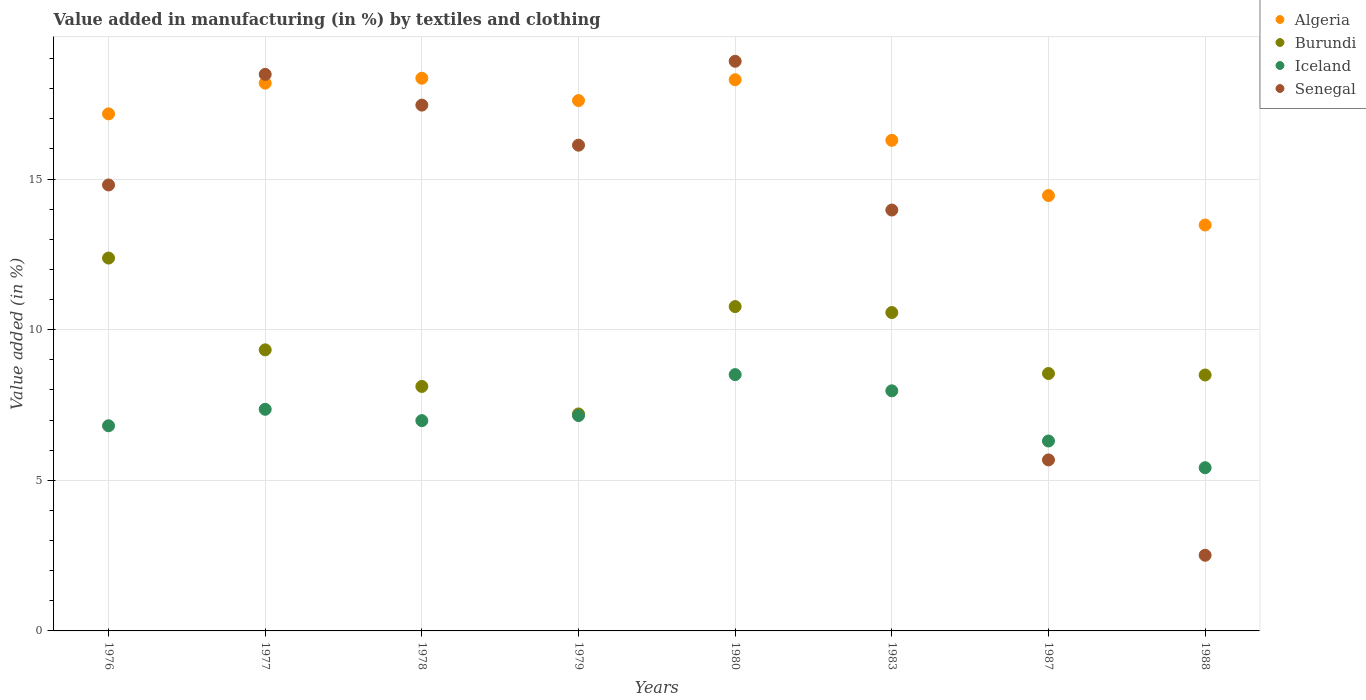How many different coloured dotlines are there?
Ensure brevity in your answer.  4. Is the number of dotlines equal to the number of legend labels?
Offer a very short reply. Yes. What is the percentage of value added in manufacturing by textiles and clothing in Burundi in 1983?
Your answer should be very brief. 10.57. Across all years, what is the maximum percentage of value added in manufacturing by textiles and clothing in Algeria?
Your response must be concise. 18.35. Across all years, what is the minimum percentage of value added in manufacturing by textiles and clothing in Iceland?
Your answer should be compact. 5.42. In which year was the percentage of value added in manufacturing by textiles and clothing in Burundi maximum?
Your answer should be very brief. 1976. What is the total percentage of value added in manufacturing by textiles and clothing in Burundi in the graph?
Keep it short and to the point. 75.4. What is the difference between the percentage of value added in manufacturing by textiles and clothing in Iceland in 1987 and that in 1988?
Make the answer very short. 0.89. What is the difference between the percentage of value added in manufacturing by textiles and clothing in Senegal in 1980 and the percentage of value added in manufacturing by textiles and clothing in Iceland in 1987?
Your answer should be compact. 12.6. What is the average percentage of value added in manufacturing by textiles and clothing in Burundi per year?
Your answer should be very brief. 9.42. In the year 1976, what is the difference between the percentage of value added in manufacturing by textiles and clothing in Algeria and percentage of value added in manufacturing by textiles and clothing in Senegal?
Provide a succinct answer. 2.36. In how many years, is the percentage of value added in manufacturing by textiles and clothing in Senegal greater than 14 %?
Ensure brevity in your answer.  5. What is the ratio of the percentage of value added in manufacturing by textiles and clothing in Algeria in 1976 to that in 1980?
Your answer should be compact. 0.94. Is the difference between the percentage of value added in manufacturing by textiles and clothing in Algeria in 1978 and 1988 greater than the difference between the percentage of value added in manufacturing by textiles and clothing in Senegal in 1978 and 1988?
Provide a short and direct response. No. What is the difference between the highest and the second highest percentage of value added in manufacturing by textiles and clothing in Iceland?
Offer a very short reply. 0.54. What is the difference between the highest and the lowest percentage of value added in manufacturing by textiles and clothing in Senegal?
Make the answer very short. 16.4. In how many years, is the percentage of value added in manufacturing by textiles and clothing in Algeria greater than the average percentage of value added in manufacturing by textiles and clothing in Algeria taken over all years?
Your answer should be very brief. 5. Is the sum of the percentage of value added in manufacturing by textiles and clothing in Algeria in 1978 and 1980 greater than the maximum percentage of value added in manufacturing by textiles and clothing in Senegal across all years?
Give a very brief answer. Yes. Does the percentage of value added in manufacturing by textiles and clothing in Iceland monotonically increase over the years?
Keep it short and to the point. No. Is the percentage of value added in manufacturing by textiles and clothing in Algeria strictly greater than the percentage of value added in manufacturing by textiles and clothing in Burundi over the years?
Keep it short and to the point. Yes. Is the percentage of value added in manufacturing by textiles and clothing in Senegal strictly less than the percentage of value added in manufacturing by textiles and clothing in Algeria over the years?
Your answer should be compact. No. What is the difference between two consecutive major ticks on the Y-axis?
Your response must be concise. 5. Are the values on the major ticks of Y-axis written in scientific E-notation?
Keep it short and to the point. No. Does the graph contain grids?
Your answer should be very brief. Yes. What is the title of the graph?
Give a very brief answer. Value added in manufacturing (in %) by textiles and clothing. What is the label or title of the X-axis?
Provide a short and direct response. Years. What is the label or title of the Y-axis?
Your answer should be very brief. Value added (in %). What is the Value added (in %) of Algeria in 1976?
Keep it short and to the point. 17.16. What is the Value added (in %) of Burundi in 1976?
Give a very brief answer. 12.38. What is the Value added (in %) of Iceland in 1976?
Your response must be concise. 6.81. What is the Value added (in %) in Senegal in 1976?
Ensure brevity in your answer.  14.8. What is the Value added (in %) in Algeria in 1977?
Keep it short and to the point. 18.18. What is the Value added (in %) of Burundi in 1977?
Offer a very short reply. 9.33. What is the Value added (in %) of Iceland in 1977?
Make the answer very short. 7.36. What is the Value added (in %) in Senegal in 1977?
Provide a succinct answer. 18.48. What is the Value added (in %) of Algeria in 1978?
Keep it short and to the point. 18.35. What is the Value added (in %) in Burundi in 1978?
Give a very brief answer. 8.12. What is the Value added (in %) of Iceland in 1978?
Your answer should be very brief. 6.98. What is the Value added (in %) of Senegal in 1978?
Your response must be concise. 17.45. What is the Value added (in %) in Algeria in 1979?
Your response must be concise. 17.6. What is the Value added (in %) of Burundi in 1979?
Give a very brief answer. 7.2. What is the Value added (in %) of Iceland in 1979?
Provide a short and direct response. 7.15. What is the Value added (in %) in Senegal in 1979?
Offer a very short reply. 16.12. What is the Value added (in %) of Algeria in 1980?
Your answer should be compact. 18.3. What is the Value added (in %) in Burundi in 1980?
Keep it short and to the point. 10.77. What is the Value added (in %) of Iceland in 1980?
Offer a terse response. 8.51. What is the Value added (in %) in Senegal in 1980?
Provide a succinct answer. 18.91. What is the Value added (in %) in Algeria in 1983?
Your answer should be very brief. 16.29. What is the Value added (in %) of Burundi in 1983?
Your answer should be very brief. 10.57. What is the Value added (in %) in Iceland in 1983?
Provide a short and direct response. 7.97. What is the Value added (in %) in Senegal in 1983?
Your answer should be very brief. 13.97. What is the Value added (in %) of Algeria in 1987?
Make the answer very short. 14.45. What is the Value added (in %) in Burundi in 1987?
Ensure brevity in your answer.  8.54. What is the Value added (in %) in Iceland in 1987?
Keep it short and to the point. 6.3. What is the Value added (in %) in Senegal in 1987?
Make the answer very short. 5.68. What is the Value added (in %) of Algeria in 1988?
Make the answer very short. 13.47. What is the Value added (in %) in Burundi in 1988?
Offer a very short reply. 8.5. What is the Value added (in %) in Iceland in 1988?
Your answer should be compact. 5.42. What is the Value added (in %) of Senegal in 1988?
Ensure brevity in your answer.  2.51. Across all years, what is the maximum Value added (in %) in Algeria?
Make the answer very short. 18.35. Across all years, what is the maximum Value added (in %) in Burundi?
Ensure brevity in your answer.  12.38. Across all years, what is the maximum Value added (in %) in Iceland?
Your answer should be compact. 8.51. Across all years, what is the maximum Value added (in %) of Senegal?
Offer a terse response. 18.91. Across all years, what is the minimum Value added (in %) of Algeria?
Your response must be concise. 13.47. Across all years, what is the minimum Value added (in %) in Burundi?
Provide a short and direct response. 7.2. Across all years, what is the minimum Value added (in %) in Iceland?
Make the answer very short. 5.42. Across all years, what is the minimum Value added (in %) of Senegal?
Provide a short and direct response. 2.51. What is the total Value added (in %) of Algeria in the graph?
Your response must be concise. 133.81. What is the total Value added (in %) of Burundi in the graph?
Your response must be concise. 75.4. What is the total Value added (in %) in Iceland in the graph?
Your answer should be compact. 56.49. What is the total Value added (in %) of Senegal in the graph?
Make the answer very short. 107.93. What is the difference between the Value added (in %) of Algeria in 1976 and that in 1977?
Your answer should be very brief. -1.02. What is the difference between the Value added (in %) in Burundi in 1976 and that in 1977?
Ensure brevity in your answer.  3.05. What is the difference between the Value added (in %) in Iceland in 1976 and that in 1977?
Your answer should be very brief. -0.55. What is the difference between the Value added (in %) in Senegal in 1976 and that in 1977?
Offer a terse response. -3.67. What is the difference between the Value added (in %) of Algeria in 1976 and that in 1978?
Your answer should be compact. -1.18. What is the difference between the Value added (in %) in Burundi in 1976 and that in 1978?
Your answer should be very brief. 4.26. What is the difference between the Value added (in %) in Iceland in 1976 and that in 1978?
Provide a succinct answer. -0.17. What is the difference between the Value added (in %) in Senegal in 1976 and that in 1978?
Give a very brief answer. -2.65. What is the difference between the Value added (in %) in Algeria in 1976 and that in 1979?
Offer a terse response. -0.44. What is the difference between the Value added (in %) of Burundi in 1976 and that in 1979?
Your answer should be compact. 5.17. What is the difference between the Value added (in %) of Iceland in 1976 and that in 1979?
Keep it short and to the point. -0.34. What is the difference between the Value added (in %) of Senegal in 1976 and that in 1979?
Provide a succinct answer. -1.32. What is the difference between the Value added (in %) of Algeria in 1976 and that in 1980?
Offer a very short reply. -1.13. What is the difference between the Value added (in %) of Burundi in 1976 and that in 1980?
Offer a terse response. 1.61. What is the difference between the Value added (in %) of Iceland in 1976 and that in 1980?
Keep it short and to the point. -1.7. What is the difference between the Value added (in %) of Senegal in 1976 and that in 1980?
Provide a short and direct response. -4.11. What is the difference between the Value added (in %) of Algeria in 1976 and that in 1983?
Offer a very short reply. 0.88. What is the difference between the Value added (in %) in Burundi in 1976 and that in 1983?
Offer a terse response. 1.81. What is the difference between the Value added (in %) in Iceland in 1976 and that in 1983?
Your answer should be very brief. -1.16. What is the difference between the Value added (in %) in Senegal in 1976 and that in 1983?
Provide a succinct answer. 0.83. What is the difference between the Value added (in %) of Algeria in 1976 and that in 1987?
Ensure brevity in your answer.  2.71. What is the difference between the Value added (in %) in Burundi in 1976 and that in 1987?
Keep it short and to the point. 3.83. What is the difference between the Value added (in %) of Iceland in 1976 and that in 1987?
Your answer should be very brief. 0.51. What is the difference between the Value added (in %) in Senegal in 1976 and that in 1987?
Your response must be concise. 9.13. What is the difference between the Value added (in %) of Algeria in 1976 and that in 1988?
Ensure brevity in your answer.  3.69. What is the difference between the Value added (in %) of Burundi in 1976 and that in 1988?
Your answer should be very brief. 3.88. What is the difference between the Value added (in %) in Iceland in 1976 and that in 1988?
Your answer should be very brief. 1.39. What is the difference between the Value added (in %) of Senegal in 1976 and that in 1988?
Offer a very short reply. 12.29. What is the difference between the Value added (in %) in Algeria in 1977 and that in 1978?
Provide a succinct answer. -0.16. What is the difference between the Value added (in %) in Burundi in 1977 and that in 1978?
Offer a terse response. 1.21. What is the difference between the Value added (in %) in Iceland in 1977 and that in 1978?
Ensure brevity in your answer.  0.38. What is the difference between the Value added (in %) of Senegal in 1977 and that in 1978?
Your answer should be very brief. 1.02. What is the difference between the Value added (in %) of Algeria in 1977 and that in 1979?
Your response must be concise. 0.58. What is the difference between the Value added (in %) of Burundi in 1977 and that in 1979?
Offer a very short reply. 2.13. What is the difference between the Value added (in %) of Iceland in 1977 and that in 1979?
Offer a very short reply. 0.21. What is the difference between the Value added (in %) of Senegal in 1977 and that in 1979?
Keep it short and to the point. 2.35. What is the difference between the Value added (in %) in Algeria in 1977 and that in 1980?
Make the answer very short. -0.11. What is the difference between the Value added (in %) in Burundi in 1977 and that in 1980?
Make the answer very short. -1.44. What is the difference between the Value added (in %) in Iceland in 1977 and that in 1980?
Provide a succinct answer. -1.15. What is the difference between the Value added (in %) of Senegal in 1977 and that in 1980?
Give a very brief answer. -0.43. What is the difference between the Value added (in %) in Algeria in 1977 and that in 1983?
Your answer should be compact. 1.9. What is the difference between the Value added (in %) in Burundi in 1977 and that in 1983?
Keep it short and to the point. -1.24. What is the difference between the Value added (in %) in Iceland in 1977 and that in 1983?
Offer a terse response. -0.61. What is the difference between the Value added (in %) in Senegal in 1977 and that in 1983?
Provide a succinct answer. 4.5. What is the difference between the Value added (in %) of Algeria in 1977 and that in 1987?
Your answer should be compact. 3.73. What is the difference between the Value added (in %) in Burundi in 1977 and that in 1987?
Provide a succinct answer. 0.79. What is the difference between the Value added (in %) in Iceland in 1977 and that in 1987?
Keep it short and to the point. 1.05. What is the difference between the Value added (in %) in Senegal in 1977 and that in 1987?
Give a very brief answer. 12.8. What is the difference between the Value added (in %) in Algeria in 1977 and that in 1988?
Ensure brevity in your answer.  4.71. What is the difference between the Value added (in %) of Burundi in 1977 and that in 1988?
Your answer should be very brief. 0.83. What is the difference between the Value added (in %) of Iceland in 1977 and that in 1988?
Provide a succinct answer. 1.94. What is the difference between the Value added (in %) in Senegal in 1977 and that in 1988?
Make the answer very short. 15.96. What is the difference between the Value added (in %) of Algeria in 1978 and that in 1979?
Your response must be concise. 0.74. What is the difference between the Value added (in %) in Burundi in 1978 and that in 1979?
Keep it short and to the point. 0.91. What is the difference between the Value added (in %) in Iceland in 1978 and that in 1979?
Make the answer very short. -0.17. What is the difference between the Value added (in %) of Senegal in 1978 and that in 1979?
Your answer should be very brief. 1.33. What is the difference between the Value added (in %) in Algeria in 1978 and that in 1980?
Keep it short and to the point. 0.05. What is the difference between the Value added (in %) of Burundi in 1978 and that in 1980?
Your answer should be compact. -2.65. What is the difference between the Value added (in %) of Iceland in 1978 and that in 1980?
Provide a succinct answer. -1.53. What is the difference between the Value added (in %) of Senegal in 1978 and that in 1980?
Make the answer very short. -1.45. What is the difference between the Value added (in %) in Algeria in 1978 and that in 1983?
Keep it short and to the point. 2.06. What is the difference between the Value added (in %) of Burundi in 1978 and that in 1983?
Provide a short and direct response. -2.45. What is the difference between the Value added (in %) in Iceland in 1978 and that in 1983?
Ensure brevity in your answer.  -0.99. What is the difference between the Value added (in %) of Senegal in 1978 and that in 1983?
Offer a very short reply. 3.48. What is the difference between the Value added (in %) of Algeria in 1978 and that in 1987?
Your response must be concise. 3.89. What is the difference between the Value added (in %) in Burundi in 1978 and that in 1987?
Provide a succinct answer. -0.43. What is the difference between the Value added (in %) of Iceland in 1978 and that in 1987?
Provide a short and direct response. 0.68. What is the difference between the Value added (in %) of Senegal in 1978 and that in 1987?
Offer a terse response. 11.78. What is the difference between the Value added (in %) of Algeria in 1978 and that in 1988?
Provide a short and direct response. 4.87. What is the difference between the Value added (in %) in Burundi in 1978 and that in 1988?
Your answer should be compact. -0.38. What is the difference between the Value added (in %) of Iceland in 1978 and that in 1988?
Your answer should be very brief. 1.56. What is the difference between the Value added (in %) of Senegal in 1978 and that in 1988?
Provide a short and direct response. 14.94. What is the difference between the Value added (in %) in Algeria in 1979 and that in 1980?
Ensure brevity in your answer.  -0.69. What is the difference between the Value added (in %) of Burundi in 1979 and that in 1980?
Your response must be concise. -3.56. What is the difference between the Value added (in %) in Iceland in 1979 and that in 1980?
Your answer should be compact. -1.36. What is the difference between the Value added (in %) in Senegal in 1979 and that in 1980?
Offer a very short reply. -2.78. What is the difference between the Value added (in %) of Algeria in 1979 and that in 1983?
Offer a very short reply. 1.32. What is the difference between the Value added (in %) of Burundi in 1979 and that in 1983?
Your answer should be very brief. -3.37. What is the difference between the Value added (in %) of Iceland in 1979 and that in 1983?
Provide a succinct answer. -0.82. What is the difference between the Value added (in %) of Senegal in 1979 and that in 1983?
Ensure brevity in your answer.  2.15. What is the difference between the Value added (in %) of Algeria in 1979 and that in 1987?
Keep it short and to the point. 3.15. What is the difference between the Value added (in %) in Burundi in 1979 and that in 1987?
Provide a succinct answer. -1.34. What is the difference between the Value added (in %) in Iceland in 1979 and that in 1987?
Offer a very short reply. 0.84. What is the difference between the Value added (in %) of Senegal in 1979 and that in 1987?
Your answer should be very brief. 10.45. What is the difference between the Value added (in %) in Algeria in 1979 and that in 1988?
Give a very brief answer. 4.13. What is the difference between the Value added (in %) in Burundi in 1979 and that in 1988?
Make the answer very short. -1.29. What is the difference between the Value added (in %) of Iceland in 1979 and that in 1988?
Offer a terse response. 1.73. What is the difference between the Value added (in %) in Senegal in 1979 and that in 1988?
Your response must be concise. 13.61. What is the difference between the Value added (in %) in Algeria in 1980 and that in 1983?
Your answer should be compact. 2.01. What is the difference between the Value added (in %) of Burundi in 1980 and that in 1983?
Offer a terse response. 0.2. What is the difference between the Value added (in %) of Iceland in 1980 and that in 1983?
Your answer should be compact. 0.54. What is the difference between the Value added (in %) of Senegal in 1980 and that in 1983?
Provide a short and direct response. 4.94. What is the difference between the Value added (in %) in Algeria in 1980 and that in 1987?
Your response must be concise. 3.84. What is the difference between the Value added (in %) of Burundi in 1980 and that in 1987?
Your answer should be very brief. 2.22. What is the difference between the Value added (in %) of Iceland in 1980 and that in 1987?
Your answer should be very brief. 2.2. What is the difference between the Value added (in %) of Senegal in 1980 and that in 1987?
Ensure brevity in your answer.  13.23. What is the difference between the Value added (in %) of Algeria in 1980 and that in 1988?
Offer a very short reply. 4.82. What is the difference between the Value added (in %) of Burundi in 1980 and that in 1988?
Provide a succinct answer. 2.27. What is the difference between the Value added (in %) of Iceland in 1980 and that in 1988?
Your answer should be compact. 3.09. What is the difference between the Value added (in %) in Senegal in 1980 and that in 1988?
Offer a very short reply. 16.4. What is the difference between the Value added (in %) of Algeria in 1983 and that in 1987?
Give a very brief answer. 1.83. What is the difference between the Value added (in %) of Burundi in 1983 and that in 1987?
Your answer should be very brief. 2.02. What is the difference between the Value added (in %) in Iceland in 1983 and that in 1987?
Provide a succinct answer. 1.67. What is the difference between the Value added (in %) in Senegal in 1983 and that in 1987?
Offer a terse response. 8.29. What is the difference between the Value added (in %) of Algeria in 1983 and that in 1988?
Your response must be concise. 2.81. What is the difference between the Value added (in %) in Burundi in 1983 and that in 1988?
Ensure brevity in your answer.  2.07. What is the difference between the Value added (in %) of Iceland in 1983 and that in 1988?
Make the answer very short. 2.55. What is the difference between the Value added (in %) in Senegal in 1983 and that in 1988?
Keep it short and to the point. 11.46. What is the difference between the Value added (in %) in Algeria in 1987 and that in 1988?
Provide a short and direct response. 0.98. What is the difference between the Value added (in %) of Burundi in 1987 and that in 1988?
Provide a succinct answer. 0.05. What is the difference between the Value added (in %) of Iceland in 1987 and that in 1988?
Provide a short and direct response. 0.89. What is the difference between the Value added (in %) of Senegal in 1987 and that in 1988?
Keep it short and to the point. 3.17. What is the difference between the Value added (in %) in Algeria in 1976 and the Value added (in %) in Burundi in 1977?
Provide a short and direct response. 7.83. What is the difference between the Value added (in %) of Algeria in 1976 and the Value added (in %) of Iceland in 1977?
Provide a succinct answer. 9.81. What is the difference between the Value added (in %) in Algeria in 1976 and the Value added (in %) in Senegal in 1977?
Make the answer very short. -1.31. What is the difference between the Value added (in %) of Burundi in 1976 and the Value added (in %) of Iceland in 1977?
Provide a succinct answer. 5.02. What is the difference between the Value added (in %) of Burundi in 1976 and the Value added (in %) of Senegal in 1977?
Give a very brief answer. -6.1. What is the difference between the Value added (in %) of Iceland in 1976 and the Value added (in %) of Senegal in 1977?
Provide a succinct answer. -11.67. What is the difference between the Value added (in %) of Algeria in 1976 and the Value added (in %) of Burundi in 1978?
Ensure brevity in your answer.  9.05. What is the difference between the Value added (in %) of Algeria in 1976 and the Value added (in %) of Iceland in 1978?
Offer a very short reply. 10.18. What is the difference between the Value added (in %) of Algeria in 1976 and the Value added (in %) of Senegal in 1978?
Offer a terse response. -0.29. What is the difference between the Value added (in %) in Burundi in 1976 and the Value added (in %) in Iceland in 1978?
Provide a succinct answer. 5.4. What is the difference between the Value added (in %) in Burundi in 1976 and the Value added (in %) in Senegal in 1978?
Provide a short and direct response. -5.08. What is the difference between the Value added (in %) in Iceland in 1976 and the Value added (in %) in Senegal in 1978?
Make the answer very short. -10.64. What is the difference between the Value added (in %) of Algeria in 1976 and the Value added (in %) of Burundi in 1979?
Your response must be concise. 9.96. What is the difference between the Value added (in %) in Algeria in 1976 and the Value added (in %) in Iceland in 1979?
Your answer should be compact. 10.02. What is the difference between the Value added (in %) of Algeria in 1976 and the Value added (in %) of Senegal in 1979?
Offer a terse response. 1.04. What is the difference between the Value added (in %) in Burundi in 1976 and the Value added (in %) in Iceland in 1979?
Your response must be concise. 5.23. What is the difference between the Value added (in %) in Burundi in 1976 and the Value added (in %) in Senegal in 1979?
Give a very brief answer. -3.75. What is the difference between the Value added (in %) of Iceland in 1976 and the Value added (in %) of Senegal in 1979?
Provide a short and direct response. -9.31. What is the difference between the Value added (in %) of Algeria in 1976 and the Value added (in %) of Burundi in 1980?
Offer a very short reply. 6.4. What is the difference between the Value added (in %) in Algeria in 1976 and the Value added (in %) in Iceland in 1980?
Your answer should be compact. 8.66. What is the difference between the Value added (in %) in Algeria in 1976 and the Value added (in %) in Senegal in 1980?
Make the answer very short. -1.75. What is the difference between the Value added (in %) of Burundi in 1976 and the Value added (in %) of Iceland in 1980?
Provide a succinct answer. 3.87. What is the difference between the Value added (in %) in Burundi in 1976 and the Value added (in %) in Senegal in 1980?
Offer a very short reply. -6.53. What is the difference between the Value added (in %) in Iceland in 1976 and the Value added (in %) in Senegal in 1980?
Offer a very short reply. -12.1. What is the difference between the Value added (in %) of Algeria in 1976 and the Value added (in %) of Burundi in 1983?
Give a very brief answer. 6.6. What is the difference between the Value added (in %) in Algeria in 1976 and the Value added (in %) in Iceland in 1983?
Keep it short and to the point. 9.19. What is the difference between the Value added (in %) of Algeria in 1976 and the Value added (in %) of Senegal in 1983?
Keep it short and to the point. 3.19. What is the difference between the Value added (in %) of Burundi in 1976 and the Value added (in %) of Iceland in 1983?
Your answer should be compact. 4.41. What is the difference between the Value added (in %) in Burundi in 1976 and the Value added (in %) in Senegal in 1983?
Provide a succinct answer. -1.59. What is the difference between the Value added (in %) of Iceland in 1976 and the Value added (in %) of Senegal in 1983?
Your response must be concise. -7.16. What is the difference between the Value added (in %) of Algeria in 1976 and the Value added (in %) of Burundi in 1987?
Provide a succinct answer. 8.62. What is the difference between the Value added (in %) of Algeria in 1976 and the Value added (in %) of Iceland in 1987?
Provide a succinct answer. 10.86. What is the difference between the Value added (in %) of Algeria in 1976 and the Value added (in %) of Senegal in 1987?
Ensure brevity in your answer.  11.49. What is the difference between the Value added (in %) of Burundi in 1976 and the Value added (in %) of Iceland in 1987?
Provide a succinct answer. 6.07. What is the difference between the Value added (in %) in Burundi in 1976 and the Value added (in %) in Senegal in 1987?
Provide a short and direct response. 6.7. What is the difference between the Value added (in %) in Iceland in 1976 and the Value added (in %) in Senegal in 1987?
Provide a short and direct response. 1.13. What is the difference between the Value added (in %) of Algeria in 1976 and the Value added (in %) of Burundi in 1988?
Give a very brief answer. 8.67. What is the difference between the Value added (in %) of Algeria in 1976 and the Value added (in %) of Iceland in 1988?
Ensure brevity in your answer.  11.75. What is the difference between the Value added (in %) of Algeria in 1976 and the Value added (in %) of Senegal in 1988?
Give a very brief answer. 14.65. What is the difference between the Value added (in %) in Burundi in 1976 and the Value added (in %) in Iceland in 1988?
Your response must be concise. 6.96. What is the difference between the Value added (in %) of Burundi in 1976 and the Value added (in %) of Senegal in 1988?
Give a very brief answer. 9.86. What is the difference between the Value added (in %) of Iceland in 1976 and the Value added (in %) of Senegal in 1988?
Keep it short and to the point. 4.3. What is the difference between the Value added (in %) in Algeria in 1977 and the Value added (in %) in Burundi in 1978?
Provide a succinct answer. 10.07. What is the difference between the Value added (in %) of Algeria in 1977 and the Value added (in %) of Iceland in 1978?
Make the answer very short. 11.2. What is the difference between the Value added (in %) of Algeria in 1977 and the Value added (in %) of Senegal in 1978?
Keep it short and to the point. 0.73. What is the difference between the Value added (in %) of Burundi in 1977 and the Value added (in %) of Iceland in 1978?
Offer a very short reply. 2.35. What is the difference between the Value added (in %) of Burundi in 1977 and the Value added (in %) of Senegal in 1978?
Provide a succinct answer. -8.12. What is the difference between the Value added (in %) of Iceland in 1977 and the Value added (in %) of Senegal in 1978?
Your answer should be very brief. -10.1. What is the difference between the Value added (in %) of Algeria in 1977 and the Value added (in %) of Burundi in 1979?
Provide a succinct answer. 10.98. What is the difference between the Value added (in %) of Algeria in 1977 and the Value added (in %) of Iceland in 1979?
Your answer should be very brief. 11.04. What is the difference between the Value added (in %) of Algeria in 1977 and the Value added (in %) of Senegal in 1979?
Your response must be concise. 2.06. What is the difference between the Value added (in %) of Burundi in 1977 and the Value added (in %) of Iceland in 1979?
Give a very brief answer. 2.18. What is the difference between the Value added (in %) of Burundi in 1977 and the Value added (in %) of Senegal in 1979?
Your response must be concise. -6.79. What is the difference between the Value added (in %) of Iceland in 1977 and the Value added (in %) of Senegal in 1979?
Provide a succinct answer. -8.77. What is the difference between the Value added (in %) of Algeria in 1977 and the Value added (in %) of Burundi in 1980?
Provide a succinct answer. 7.42. What is the difference between the Value added (in %) in Algeria in 1977 and the Value added (in %) in Iceland in 1980?
Your answer should be very brief. 9.68. What is the difference between the Value added (in %) of Algeria in 1977 and the Value added (in %) of Senegal in 1980?
Provide a short and direct response. -0.73. What is the difference between the Value added (in %) in Burundi in 1977 and the Value added (in %) in Iceland in 1980?
Provide a short and direct response. 0.82. What is the difference between the Value added (in %) of Burundi in 1977 and the Value added (in %) of Senegal in 1980?
Provide a short and direct response. -9.58. What is the difference between the Value added (in %) of Iceland in 1977 and the Value added (in %) of Senegal in 1980?
Your answer should be compact. -11.55. What is the difference between the Value added (in %) in Algeria in 1977 and the Value added (in %) in Burundi in 1983?
Provide a short and direct response. 7.61. What is the difference between the Value added (in %) in Algeria in 1977 and the Value added (in %) in Iceland in 1983?
Your response must be concise. 10.21. What is the difference between the Value added (in %) in Algeria in 1977 and the Value added (in %) in Senegal in 1983?
Offer a very short reply. 4.21. What is the difference between the Value added (in %) of Burundi in 1977 and the Value added (in %) of Iceland in 1983?
Your response must be concise. 1.36. What is the difference between the Value added (in %) of Burundi in 1977 and the Value added (in %) of Senegal in 1983?
Your answer should be very brief. -4.64. What is the difference between the Value added (in %) of Iceland in 1977 and the Value added (in %) of Senegal in 1983?
Keep it short and to the point. -6.61. What is the difference between the Value added (in %) of Algeria in 1977 and the Value added (in %) of Burundi in 1987?
Your answer should be compact. 9.64. What is the difference between the Value added (in %) in Algeria in 1977 and the Value added (in %) in Iceland in 1987?
Provide a short and direct response. 11.88. What is the difference between the Value added (in %) in Algeria in 1977 and the Value added (in %) in Senegal in 1987?
Your answer should be very brief. 12.51. What is the difference between the Value added (in %) in Burundi in 1977 and the Value added (in %) in Iceland in 1987?
Your response must be concise. 3.03. What is the difference between the Value added (in %) in Burundi in 1977 and the Value added (in %) in Senegal in 1987?
Give a very brief answer. 3.65. What is the difference between the Value added (in %) of Iceland in 1977 and the Value added (in %) of Senegal in 1987?
Make the answer very short. 1.68. What is the difference between the Value added (in %) of Algeria in 1977 and the Value added (in %) of Burundi in 1988?
Ensure brevity in your answer.  9.69. What is the difference between the Value added (in %) of Algeria in 1977 and the Value added (in %) of Iceland in 1988?
Your answer should be compact. 12.77. What is the difference between the Value added (in %) of Algeria in 1977 and the Value added (in %) of Senegal in 1988?
Give a very brief answer. 15.67. What is the difference between the Value added (in %) of Burundi in 1977 and the Value added (in %) of Iceland in 1988?
Your answer should be very brief. 3.91. What is the difference between the Value added (in %) of Burundi in 1977 and the Value added (in %) of Senegal in 1988?
Offer a very short reply. 6.82. What is the difference between the Value added (in %) in Iceland in 1977 and the Value added (in %) in Senegal in 1988?
Provide a short and direct response. 4.85. What is the difference between the Value added (in %) of Algeria in 1978 and the Value added (in %) of Burundi in 1979?
Make the answer very short. 11.14. What is the difference between the Value added (in %) in Algeria in 1978 and the Value added (in %) in Iceland in 1979?
Your answer should be very brief. 11.2. What is the difference between the Value added (in %) of Algeria in 1978 and the Value added (in %) of Senegal in 1979?
Offer a very short reply. 2.22. What is the difference between the Value added (in %) in Burundi in 1978 and the Value added (in %) in Iceland in 1979?
Provide a succinct answer. 0.97. What is the difference between the Value added (in %) of Burundi in 1978 and the Value added (in %) of Senegal in 1979?
Offer a very short reply. -8.01. What is the difference between the Value added (in %) of Iceland in 1978 and the Value added (in %) of Senegal in 1979?
Ensure brevity in your answer.  -9.14. What is the difference between the Value added (in %) of Algeria in 1978 and the Value added (in %) of Burundi in 1980?
Your answer should be very brief. 7.58. What is the difference between the Value added (in %) of Algeria in 1978 and the Value added (in %) of Iceland in 1980?
Your answer should be very brief. 9.84. What is the difference between the Value added (in %) in Algeria in 1978 and the Value added (in %) in Senegal in 1980?
Your answer should be very brief. -0.56. What is the difference between the Value added (in %) in Burundi in 1978 and the Value added (in %) in Iceland in 1980?
Your answer should be compact. -0.39. What is the difference between the Value added (in %) in Burundi in 1978 and the Value added (in %) in Senegal in 1980?
Ensure brevity in your answer.  -10.79. What is the difference between the Value added (in %) of Iceland in 1978 and the Value added (in %) of Senegal in 1980?
Keep it short and to the point. -11.93. What is the difference between the Value added (in %) in Algeria in 1978 and the Value added (in %) in Burundi in 1983?
Provide a succinct answer. 7.78. What is the difference between the Value added (in %) in Algeria in 1978 and the Value added (in %) in Iceland in 1983?
Your response must be concise. 10.38. What is the difference between the Value added (in %) of Algeria in 1978 and the Value added (in %) of Senegal in 1983?
Give a very brief answer. 4.37. What is the difference between the Value added (in %) of Burundi in 1978 and the Value added (in %) of Iceland in 1983?
Your response must be concise. 0.15. What is the difference between the Value added (in %) in Burundi in 1978 and the Value added (in %) in Senegal in 1983?
Provide a short and direct response. -5.86. What is the difference between the Value added (in %) in Iceland in 1978 and the Value added (in %) in Senegal in 1983?
Offer a very short reply. -6.99. What is the difference between the Value added (in %) in Algeria in 1978 and the Value added (in %) in Burundi in 1987?
Make the answer very short. 9.8. What is the difference between the Value added (in %) of Algeria in 1978 and the Value added (in %) of Iceland in 1987?
Make the answer very short. 12.04. What is the difference between the Value added (in %) in Algeria in 1978 and the Value added (in %) in Senegal in 1987?
Your answer should be very brief. 12.67. What is the difference between the Value added (in %) in Burundi in 1978 and the Value added (in %) in Iceland in 1987?
Keep it short and to the point. 1.81. What is the difference between the Value added (in %) of Burundi in 1978 and the Value added (in %) of Senegal in 1987?
Your answer should be compact. 2.44. What is the difference between the Value added (in %) in Iceland in 1978 and the Value added (in %) in Senegal in 1987?
Keep it short and to the point. 1.3. What is the difference between the Value added (in %) in Algeria in 1978 and the Value added (in %) in Burundi in 1988?
Offer a terse response. 9.85. What is the difference between the Value added (in %) in Algeria in 1978 and the Value added (in %) in Iceland in 1988?
Ensure brevity in your answer.  12.93. What is the difference between the Value added (in %) of Algeria in 1978 and the Value added (in %) of Senegal in 1988?
Your answer should be very brief. 15.83. What is the difference between the Value added (in %) of Burundi in 1978 and the Value added (in %) of Iceland in 1988?
Offer a very short reply. 2.7. What is the difference between the Value added (in %) of Burundi in 1978 and the Value added (in %) of Senegal in 1988?
Your answer should be compact. 5.6. What is the difference between the Value added (in %) in Iceland in 1978 and the Value added (in %) in Senegal in 1988?
Offer a terse response. 4.47. What is the difference between the Value added (in %) of Algeria in 1979 and the Value added (in %) of Burundi in 1980?
Your answer should be very brief. 6.84. What is the difference between the Value added (in %) of Algeria in 1979 and the Value added (in %) of Iceland in 1980?
Your answer should be very brief. 9.1. What is the difference between the Value added (in %) of Algeria in 1979 and the Value added (in %) of Senegal in 1980?
Keep it short and to the point. -1.3. What is the difference between the Value added (in %) in Burundi in 1979 and the Value added (in %) in Iceland in 1980?
Provide a short and direct response. -1.31. What is the difference between the Value added (in %) of Burundi in 1979 and the Value added (in %) of Senegal in 1980?
Your response must be concise. -11.71. What is the difference between the Value added (in %) in Iceland in 1979 and the Value added (in %) in Senegal in 1980?
Your response must be concise. -11.76. What is the difference between the Value added (in %) in Algeria in 1979 and the Value added (in %) in Burundi in 1983?
Your response must be concise. 7.04. What is the difference between the Value added (in %) of Algeria in 1979 and the Value added (in %) of Iceland in 1983?
Offer a terse response. 9.63. What is the difference between the Value added (in %) of Algeria in 1979 and the Value added (in %) of Senegal in 1983?
Make the answer very short. 3.63. What is the difference between the Value added (in %) of Burundi in 1979 and the Value added (in %) of Iceland in 1983?
Ensure brevity in your answer.  -0.77. What is the difference between the Value added (in %) in Burundi in 1979 and the Value added (in %) in Senegal in 1983?
Offer a terse response. -6.77. What is the difference between the Value added (in %) in Iceland in 1979 and the Value added (in %) in Senegal in 1983?
Provide a short and direct response. -6.82. What is the difference between the Value added (in %) in Algeria in 1979 and the Value added (in %) in Burundi in 1987?
Provide a succinct answer. 9.06. What is the difference between the Value added (in %) in Algeria in 1979 and the Value added (in %) in Iceland in 1987?
Your answer should be compact. 11.3. What is the difference between the Value added (in %) in Algeria in 1979 and the Value added (in %) in Senegal in 1987?
Keep it short and to the point. 11.93. What is the difference between the Value added (in %) of Burundi in 1979 and the Value added (in %) of Iceland in 1987?
Ensure brevity in your answer.  0.9. What is the difference between the Value added (in %) of Burundi in 1979 and the Value added (in %) of Senegal in 1987?
Offer a very short reply. 1.53. What is the difference between the Value added (in %) in Iceland in 1979 and the Value added (in %) in Senegal in 1987?
Your answer should be compact. 1.47. What is the difference between the Value added (in %) of Algeria in 1979 and the Value added (in %) of Burundi in 1988?
Your answer should be very brief. 9.11. What is the difference between the Value added (in %) in Algeria in 1979 and the Value added (in %) in Iceland in 1988?
Offer a very short reply. 12.19. What is the difference between the Value added (in %) in Algeria in 1979 and the Value added (in %) in Senegal in 1988?
Your answer should be very brief. 15.09. What is the difference between the Value added (in %) of Burundi in 1979 and the Value added (in %) of Iceland in 1988?
Provide a succinct answer. 1.78. What is the difference between the Value added (in %) of Burundi in 1979 and the Value added (in %) of Senegal in 1988?
Keep it short and to the point. 4.69. What is the difference between the Value added (in %) of Iceland in 1979 and the Value added (in %) of Senegal in 1988?
Your answer should be compact. 4.64. What is the difference between the Value added (in %) in Algeria in 1980 and the Value added (in %) in Burundi in 1983?
Provide a succinct answer. 7.73. What is the difference between the Value added (in %) in Algeria in 1980 and the Value added (in %) in Iceland in 1983?
Your answer should be compact. 10.33. What is the difference between the Value added (in %) in Algeria in 1980 and the Value added (in %) in Senegal in 1983?
Provide a succinct answer. 4.33. What is the difference between the Value added (in %) of Burundi in 1980 and the Value added (in %) of Iceland in 1983?
Provide a succinct answer. 2.8. What is the difference between the Value added (in %) in Burundi in 1980 and the Value added (in %) in Senegal in 1983?
Your answer should be compact. -3.2. What is the difference between the Value added (in %) in Iceland in 1980 and the Value added (in %) in Senegal in 1983?
Offer a very short reply. -5.46. What is the difference between the Value added (in %) of Algeria in 1980 and the Value added (in %) of Burundi in 1987?
Make the answer very short. 9.75. What is the difference between the Value added (in %) in Algeria in 1980 and the Value added (in %) in Iceland in 1987?
Offer a terse response. 11.99. What is the difference between the Value added (in %) of Algeria in 1980 and the Value added (in %) of Senegal in 1987?
Your answer should be compact. 12.62. What is the difference between the Value added (in %) of Burundi in 1980 and the Value added (in %) of Iceland in 1987?
Your answer should be compact. 4.46. What is the difference between the Value added (in %) of Burundi in 1980 and the Value added (in %) of Senegal in 1987?
Your answer should be very brief. 5.09. What is the difference between the Value added (in %) of Iceland in 1980 and the Value added (in %) of Senegal in 1987?
Provide a short and direct response. 2.83. What is the difference between the Value added (in %) in Algeria in 1980 and the Value added (in %) in Burundi in 1988?
Provide a short and direct response. 9.8. What is the difference between the Value added (in %) in Algeria in 1980 and the Value added (in %) in Iceland in 1988?
Make the answer very short. 12.88. What is the difference between the Value added (in %) of Algeria in 1980 and the Value added (in %) of Senegal in 1988?
Your response must be concise. 15.78. What is the difference between the Value added (in %) of Burundi in 1980 and the Value added (in %) of Iceland in 1988?
Provide a succinct answer. 5.35. What is the difference between the Value added (in %) in Burundi in 1980 and the Value added (in %) in Senegal in 1988?
Provide a succinct answer. 8.25. What is the difference between the Value added (in %) in Iceland in 1980 and the Value added (in %) in Senegal in 1988?
Provide a short and direct response. 6. What is the difference between the Value added (in %) in Algeria in 1983 and the Value added (in %) in Burundi in 1987?
Offer a terse response. 7.74. What is the difference between the Value added (in %) of Algeria in 1983 and the Value added (in %) of Iceland in 1987?
Keep it short and to the point. 9.98. What is the difference between the Value added (in %) in Algeria in 1983 and the Value added (in %) in Senegal in 1987?
Keep it short and to the point. 10.61. What is the difference between the Value added (in %) in Burundi in 1983 and the Value added (in %) in Iceland in 1987?
Keep it short and to the point. 4.26. What is the difference between the Value added (in %) of Burundi in 1983 and the Value added (in %) of Senegal in 1987?
Keep it short and to the point. 4.89. What is the difference between the Value added (in %) of Iceland in 1983 and the Value added (in %) of Senegal in 1987?
Your response must be concise. 2.29. What is the difference between the Value added (in %) of Algeria in 1983 and the Value added (in %) of Burundi in 1988?
Your response must be concise. 7.79. What is the difference between the Value added (in %) of Algeria in 1983 and the Value added (in %) of Iceland in 1988?
Ensure brevity in your answer.  10.87. What is the difference between the Value added (in %) in Algeria in 1983 and the Value added (in %) in Senegal in 1988?
Your answer should be very brief. 13.77. What is the difference between the Value added (in %) in Burundi in 1983 and the Value added (in %) in Iceland in 1988?
Offer a terse response. 5.15. What is the difference between the Value added (in %) in Burundi in 1983 and the Value added (in %) in Senegal in 1988?
Your response must be concise. 8.06. What is the difference between the Value added (in %) of Iceland in 1983 and the Value added (in %) of Senegal in 1988?
Offer a very short reply. 5.46. What is the difference between the Value added (in %) of Algeria in 1987 and the Value added (in %) of Burundi in 1988?
Offer a terse response. 5.96. What is the difference between the Value added (in %) in Algeria in 1987 and the Value added (in %) in Iceland in 1988?
Provide a short and direct response. 9.04. What is the difference between the Value added (in %) in Algeria in 1987 and the Value added (in %) in Senegal in 1988?
Give a very brief answer. 11.94. What is the difference between the Value added (in %) of Burundi in 1987 and the Value added (in %) of Iceland in 1988?
Provide a short and direct response. 3.13. What is the difference between the Value added (in %) in Burundi in 1987 and the Value added (in %) in Senegal in 1988?
Your answer should be very brief. 6.03. What is the difference between the Value added (in %) of Iceland in 1987 and the Value added (in %) of Senegal in 1988?
Offer a very short reply. 3.79. What is the average Value added (in %) in Algeria per year?
Provide a succinct answer. 16.73. What is the average Value added (in %) in Burundi per year?
Provide a short and direct response. 9.42. What is the average Value added (in %) in Iceland per year?
Offer a very short reply. 7.06. What is the average Value added (in %) in Senegal per year?
Give a very brief answer. 13.49. In the year 1976, what is the difference between the Value added (in %) of Algeria and Value added (in %) of Burundi?
Ensure brevity in your answer.  4.79. In the year 1976, what is the difference between the Value added (in %) of Algeria and Value added (in %) of Iceland?
Provide a succinct answer. 10.35. In the year 1976, what is the difference between the Value added (in %) in Algeria and Value added (in %) in Senegal?
Ensure brevity in your answer.  2.36. In the year 1976, what is the difference between the Value added (in %) of Burundi and Value added (in %) of Iceland?
Your response must be concise. 5.57. In the year 1976, what is the difference between the Value added (in %) of Burundi and Value added (in %) of Senegal?
Offer a terse response. -2.43. In the year 1976, what is the difference between the Value added (in %) in Iceland and Value added (in %) in Senegal?
Give a very brief answer. -7.99. In the year 1977, what is the difference between the Value added (in %) of Algeria and Value added (in %) of Burundi?
Make the answer very short. 8.85. In the year 1977, what is the difference between the Value added (in %) in Algeria and Value added (in %) in Iceland?
Your answer should be compact. 10.83. In the year 1977, what is the difference between the Value added (in %) in Algeria and Value added (in %) in Senegal?
Give a very brief answer. -0.29. In the year 1977, what is the difference between the Value added (in %) of Burundi and Value added (in %) of Iceland?
Offer a very short reply. 1.97. In the year 1977, what is the difference between the Value added (in %) in Burundi and Value added (in %) in Senegal?
Make the answer very short. -9.15. In the year 1977, what is the difference between the Value added (in %) of Iceland and Value added (in %) of Senegal?
Make the answer very short. -11.12. In the year 1978, what is the difference between the Value added (in %) in Algeria and Value added (in %) in Burundi?
Give a very brief answer. 10.23. In the year 1978, what is the difference between the Value added (in %) in Algeria and Value added (in %) in Iceland?
Offer a very short reply. 11.37. In the year 1978, what is the difference between the Value added (in %) in Algeria and Value added (in %) in Senegal?
Your answer should be very brief. 0.89. In the year 1978, what is the difference between the Value added (in %) of Burundi and Value added (in %) of Iceland?
Offer a very short reply. 1.14. In the year 1978, what is the difference between the Value added (in %) of Burundi and Value added (in %) of Senegal?
Your answer should be very brief. -9.34. In the year 1978, what is the difference between the Value added (in %) of Iceland and Value added (in %) of Senegal?
Your answer should be compact. -10.47. In the year 1979, what is the difference between the Value added (in %) in Algeria and Value added (in %) in Burundi?
Make the answer very short. 10.4. In the year 1979, what is the difference between the Value added (in %) in Algeria and Value added (in %) in Iceland?
Offer a terse response. 10.46. In the year 1979, what is the difference between the Value added (in %) of Algeria and Value added (in %) of Senegal?
Give a very brief answer. 1.48. In the year 1979, what is the difference between the Value added (in %) of Burundi and Value added (in %) of Iceland?
Make the answer very short. 0.05. In the year 1979, what is the difference between the Value added (in %) in Burundi and Value added (in %) in Senegal?
Offer a very short reply. -8.92. In the year 1979, what is the difference between the Value added (in %) in Iceland and Value added (in %) in Senegal?
Keep it short and to the point. -8.98. In the year 1980, what is the difference between the Value added (in %) in Algeria and Value added (in %) in Burundi?
Ensure brevity in your answer.  7.53. In the year 1980, what is the difference between the Value added (in %) of Algeria and Value added (in %) of Iceland?
Make the answer very short. 9.79. In the year 1980, what is the difference between the Value added (in %) in Algeria and Value added (in %) in Senegal?
Make the answer very short. -0.61. In the year 1980, what is the difference between the Value added (in %) of Burundi and Value added (in %) of Iceland?
Your answer should be compact. 2.26. In the year 1980, what is the difference between the Value added (in %) of Burundi and Value added (in %) of Senegal?
Offer a terse response. -8.14. In the year 1980, what is the difference between the Value added (in %) in Iceland and Value added (in %) in Senegal?
Offer a terse response. -10.4. In the year 1983, what is the difference between the Value added (in %) of Algeria and Value added (in %) of Burundi?
Offer a very short reply. 5.72. In the year 1983, what is the difference between the Value added (in %) in Algeria and Value added (in %) in Iceland?
Offer a terse response. 8.32. In the year 1983, what is the difference between the Value added (in %) of Algeria and Value added (in %) of Senegal?
Your response must be concise. 2.31. In the year 1983, what is the difference between the Value added (in %) of Burundi and Value added (in %) of Iceland?
Provide a succinct answer. 2.6. In the year 1983, what is the difference between the Value added (in %) of Burundi and Value added (in %) of Senegal?
Offer a very short reply. -3.4. In the year 1983, what is the difference between the Value added (in %) in Iceland and Value added (in %) in Senegal?
Offer a very short reply. -6. In the year 1987, what is the difference between the Value added (in %) in Algeria and Value added (in %) in Burundi?
Offer a very short reply. 5.91. In the year 1987, what is the difference between the Value added (in %) in Algeria and Value added (in %) in Iceland?
Your answer should be compact. 8.15. In the year 1987, what is the difference between the Value added (in %) of Algeria and Value added (in %) of Senegal?
Make the answer very short. 8.78. In the year 1987, what is the difference between the Value added (in %) of Burundi and Value added (in %) of Iceland?
Offer a terse response. 2.24. In the year 1987, what is the difference between the Value added (in %) of Burundi and Value added (in %) of Senegal?
Give a very brief answer. 2.87. In the year 1987, what is the difference between the Value added (in %) in Iceland and Value added (in %) in Senegal?
Offer a terse response. 0.63. In the year 1988, what is the difference between the Value added (in %) in Algeria and Value added (in %) in Burundi?
Your answer should be very brief. 4.98. In the year 1988, what is the difference between the Value added (in %) in Algeria and Value added (in %) in Iceland?
Give a very brief answer. 8.06. In the year 1988, what is the difference between the Value added (in %) in Algeria and Value added (in %) in Senegal?
Give a very brief answer. 10.96. In the year 1988, what is the difference between the Value added (in %) in Burundi and Value added (in %) in Iceland?
Your answer should be very brief. 3.08. In the year 1988, what is the difference between the Value added (in %) of Burundi and Value added (in %) of Senegal?
Provide a succinct answer. 5.98. In the year 1988, what is the difference between the Value added (in %) of Iceland and Value added (in %) of Senegal?
Your answer should be compact. 2.91. What is the ratio of the Value added (in %) of Algeria in 1976 to that in 1977?
Make the answer very short. 0.94. What is the ratio of the Value added (in %) of Burundi in 1976 to that in 1977?
Make the answer very short. 1.33. What is the ratio of the Value added (in %) of Iceland in 1976 to that in 1977?
Offer a very short reply. 0.93. What is the ratio of the Value added (in %) of Senegal in 1976 to that in 1977?
Your answer should be very brief. 0.8. What is the ratio of the Value added (in %) in Algeria in 1976 to that in 1978?
Keep it short and to the point. 0.94. What is the ratio of the Value added (in %) of Burundi in 1976 to that in 1978?
Your answer should be very brief. 1.52. What is the ratio of the Value added (in %) in Iceland in 1976 to that in 1978?
Your response must be concise. 0.98. What is the ratio of the Value added (in %) in Senegal in 1976 to that in 1978?
Your answer should be very brief. 0.85. What is the ratio of the Value added (in %) in Burundi in 1976 to that in 1979?
Ensure brevity in your answer.  1.72. What is the ratio of the Value added (in %) in Iceland in 1976 to that in 1979?
Provide a short and direct response. 0.95. What is the ratio of the Value added (in %) of Senegal in 1976 to that in 1979?
Offer a terse response. 0.92. What is the ratio of the Value added (in %) of Algeria in 1976 to that in 1980?
Ensure brevity in your answer.  0.94. What is the ratio of the Value added (in %) of Burundi in 1976 to that in 1980?
Provide a short and direct response. 1.15. What is the ratio of the Value added (in %) in Iceland in 1976 to that in 1980?
Your answer should be compact. 0.8. What is the ratio of the Value added (in %) in Senegal in 1976 to that in 1980?
Make the answer very short. 0.78. What is the ratio of the Value added (in %) of Algeria in 1976 to that in 1983?
Provide a short and direct response. 1.05. What is the ratio of the Value added (in %) in Burundi in 1976 to that in 1983?
Provide a succinct answer. 1.17. What is the ratio of the Value added (in %) in Iceland in 1976 to that in 1983?
Your answer should be compact. 0.85. What is the ratio of the Value added (in %) in Senegal in 1976 to that in 1983?
Provide a succinct answer. 1.06. What is the ratio of the Value added (in %) in Algeria in 1976 to that in 1987?
Provide a short and direct response. 1.19. What is the ratio of the Value added (in %) of Burundi in 1976 to that in 1987?
Provide a succinct answer. 1.45. What is the ratio of the Value added (in %) of Iceland in 1976 to that in 1987?
Provide a succinct answer. 1.08. What is the ratio of the Value added (in %) in Senegal in 1976 to that in 1987?
Your response must be concise. 2.61. What is the ratio of the Value added (in %) of Algeria in 1976 to that in 1988?
Keep it short and to the point. 1.27. What is the ratio of the Value added (in %) of Burundi in 1976 to that in 1988?
Offer a very short reply. 1.46. What is the ratio of the Value added (in %) in Iceland in 1976 to that in 1988?
Ensure brevity in your answer.  1.26. What is the ratio of the Value added (in %) of Senegal in 1976 to that in 1988?
Keep it short and to the point. 5.89. What is the ratio of the Value added (in %) in Algeria in 1977 to that in 1978?
Provide a succinct answer. 0.99. What is the ratio of the Value added (in %) in Burundi in 1977 to that in 1978?
Provide a short and direct response. 1.15. What is the ratio of the Value added (in %) of Iceland in 1977 to that in 1978?
Ensure brevity in your answer.  1.05. What is the ratio of the Value added (in %) in Senegal in 1977 to that in 1978?
Give a very brief answer. 1.06. What is the ratio of the Value added (in %) of Algeria in 1977 to that in 1979?
Your answer should be compact. 1.03. What is the ratio of the Value added (in %) of Burundi in 1977 to that in 1979?
Give a very brief answer. 1.3. What is the ratio of the Value added (in %) in Iceland in 1977 to that in 1979?
Ensure brevity in your answer.  1.03. What is the ratio of the Value added (in %) of Senegal in 1977 to that in 1979?
Ensure brevity in your answer.  1.15. What is the ratio of the Value added (in %) in Algeria in 1977 to that in 1980?
Keep it short and to the point. 0.99. What is the ratio of the Value added (in %) of Burundi in 1977 to that in 1980?
Your answer should be very brief. 0.87. What is the ratio of the Value added (in %) in Iceland in 1977 to that in 1980?
Provide a short and direct response. 0.86. What is the ratio of the Value added (in %) in Senegal in 1977 to that in 1980?
Make the answer very short. 0.98. What is the ratio of the Value added (in %) in Algeria in 1977 to that in 1983?
Make the answer very short. 1.12. What is the ratio of the Value added (in %) in Burundi in 1977 to that in 1983?
Give a very brief answer. 0.88. What is the ratio of the Value added (in %) in Iceland in 1977 to that in 1983?
Offer a very short reply. 0.92. What is the ratio of the Value added (in %) of Senegal in 1977 to that in 1983?
Provide a short and direct response. 1.32. What is the ratio of the Value added (in %) in Algeria in 1977 to that in 1987?
Keep it short and to the point. 1.26. What is the ratio of the Value added (in %) of Burundi in 1977 to that in 1987?
Offer a very short reply. 1.09. What is the ratio of the Value added (in %) in Iceland in 1977 to that in 1987?
Offer a terse response. 1.17. What is the ratio of the Value added (in %) of Senegal in 1977 to that in 1987?
Give a very brief answer. 3.25. What is the ratio of the Value added (in %) of Algeria in 1977 to that in 1988?
Give a very brief answer. 1.35. What is the ratio of the Value added (in %) of Burundi in 1977 to that in 1988?
Provide a short and direct response. 1.1. What is the ratio of the Value added (in %) of Iceland in 1977 to that in 1988?
Your response must be concise. 1.36. What is the ratio of the Value added (in %) in Senegal in 1977 to that in 1988?
Ensure brevity in your answer.  7.36. What is the ratio of the Value added (in %) of Algeria in 1978 to that in 1979?
Your response must be concise. 1.04. What is the ratio of the Value added (in %) of Burundi in 1978 to that in 1979?
Provide a succinct answer. 1.13. What is the ratio of the Value added (in %) in Iceland in 1978 to that in 1979?
Give a very brief answer. 0.98. What is the ratio of the Value added (in %) of Senegal in 1978 to that in 1979?
Provide a short and direct response. 1.08. What is the ratio of the Value added (in %) in Algeria in 1978 to that in 1980?
Make the answer very short. 1. What is the ratio of the Value added (in %) in Burundi in 1978 to that in 1980?
Your answer should be compact. 0.75. What is the ratio of the Value added (in %) in Iceland in 1978 to that in 1980?
Your answer should be very brief. 0.82. What is the ratio of the Value added (in %) in Senegal in 1978 to that in 1980?
Your answer should be very brief. 0.92. What is the ratio of the Value added (in %) in Algeria in 1978 to that in 1983?
Make the answer very short. 1.13. What is the ratio of the Value added (in %) in Burundi in 1978 to that in 1983?
Offer a very short reply. 0.77. What is the ratio of the Value added (in %) of Iceland in 1978 to that in 1983?
Make the answer very short. 0.88. What is the ratio of the Value added (in %) of Senegal in 1978 to that in 1983?
Provide a short and direct response. 1.25. What is the ratio of the Value added (in %) of Algeria in 1978 to that in 1987?
Give a very brief answer. 1.27. What is the ratio of the Value added (in %) of Burundi in 1978 to that in 1987?
Your answer should be very brief. 0.95. What is the ratio of the Value added (in %) of Iceland in 1978 to that in 1987?
Make the answer very short. 1.11. What is the ratio of the Value added (in %) of Senegal in 1978 to that in 1987?
Your answer should be compact. 3.07. What is the ratio of the Value added (in %) in Algeria in 1978 to that in 1988?
Offer a terse response. 1.36. What is the ratio of the Value added (in %) of Burundi in 1978 to that in 1988?
Keep it short and to the point. 0.96. What is the ratio of the Value added (in %) of Iceland in 1978 to that in 1988?
Offer a terse response. 1.29. What is the ratio of the Value added (in %) of Senegal in 1978 to that in 1988?
Give a very brief answer. 6.95. What is the ratio of the Value added (in %) in Algeria in 1979 to that in 1980?
Your answer should be compact. 0.96. What is the ratio of the Value added (in %) in Burundi in 1979 to that in 1980?
Your response must be concise. 0.67. What is the ratio of the Value added (in %) in Iceland in 1979 to that in 1980?
Your answer should be very brief. 0.84. What is the ratio of the Value added (in %) of Senegal in 1979 to that in 1980?
Give a very brief answer. 0.85. What is the ratio of the Value added (in %) in Algeria in 1979 to that in 1983?
Ensure brevity in your answer.  1.08. What is the ratio of the Value added (in %) in Burundi in 1979 to that in 1983?
Your answer should be very brief. 0.68. What is the ratio of the Value added (in %) in Iceland in 1979 to that in 1983?
Provide a short and direct response. 0.9. What is the ratio of the Value added (in %) in Senegal in 1979 to that in 1983?
Your answer should be very brief. 1.15. What is the ratio of the Value added (in %) of Algeria in 1979 to that in 1987?
Make the answer very short. 1.22. What is the ratio of the Value added (in %) of Burundi in 1979 to that in 1987?
Give a very brief answer. 0.84. What is the ratio of the Value added (in %) in Iceland in 1979 to that in 1987?
Your response must be concise. 1.13. What is the ratio of the Value added (in %) in Senegal in 1979 to that in 1987?
Your answer should be very brief. 2.84. What is the ratio of the Value added (in %) in Algeria in 1979 to that in 1988?
Give a very brief answer. 1.31. What is the ratio of the Value added (in %) in Burundi in 1979 to that in 1988?
Your answer should be very brief. 0.85. What is the ratio of the Value added (in %) of Iceland in 1979 to that in 1988?
Your response must be concise. 1.32. What is the ratio of the Value added (in %) in Senegal in 1979 to that in 1988?
Your response must be concise. 6.42. What is the ratio of the Value added (in %) in Algeria in 1980 to that in 1983?
Your response must be concise. 1.12. What is the ratio of the Value added (in %) in Burundi in 1980 to that in 1983?
Ensure brevity in your answer.  1.02. What is the ratio of the Value added (in %) in Iceland in 1980 to that in 1983?
Make the answer very short. 1.07. What is the ratio of the Value added (in %) of Senegal in 1980 to that in 1983?
Ensure brevity in your answer.  1.35. What is the ratio of the Value added (in %) in Algeria in 1980 to that in 1987?
Your answer should be very brief. 1.27. What is the ratio of the Value added (in %) in Burundi in 1980 to that in 1987?
Keep it short and to the point. 1.26. What is the ratio of the Value added (in %) of Iceland in 1980 to that in 1987?
Your answer should be very brief. 1.35. What is the ratio of the Value added (in %) of Senegal in 1980 to that in 1987?
Your answer should be very brief. 3.33. What is the ratio of the Value added (in %) in Algeria in 1980 to that in 1988?
Offer a terse response. 1.36. What is the ratio of the Value added (in %) in Burundi in 1980 to that in 1988?
Give a very brief answer. 1.27. What is the ratio of the Value added (in %) in Iceland in 1980 to that in 1988?
Your answer should be compact. 1.57. What is the ratio of the Value added (in %) in Senegal in 1980 to that in 1988?
Keep it short and to the point. 7.53. What is the ratio of the Value added (in %) of Algeria in 1983 to that in 1987?
Ensure brevity in your answer.  1.13. What is the ratio of the Value added (in %) of Burundi in 1983 to that in 1987?
Make the answer very short. 1.24. What is the ratio of the Value added (in %) in Iceland in 1983 to that in 1987?
Provide a succinct answer. 1.26. What is the ratio of the Value added (in %) in Senegal in 1983 to that in 1987?
Your response must be concise. 2.46. What is the ratio of the Value added (in %) of Algeria in 1983 to that in 1988?
Your answer should be very brief. 1.21. What is the ratio of the Value added (in %) in Burundi in 1983 to that in 1988?
Your answer should be very brief. 1.24. What is the ratio of the Value added (in %) in Iceland in 1983 to that in 1988?
Your answer should be very brief. 1.47. What is the ratio of the Value added (in %) of Senegal in 1983 to that in 1988?
Offer a very short reply. 5.56. What is the ratio of the Value added (in %) in Algeria in 1987 to that in 1988?
Give a very brief answer. 1.07. What is the ratio of the Value added (in %) in Iceland in 1987 to that in 1988?
Provide a succinct answer. 1.16. What is the ratio of the Value added (in %) in Senegal in 1987 to that in 1988?
Provide a succinct answer. 2.26. What is the difference between the highest and the second highest Value added (in %) in Algeria?
Offer a terse response. 0.05. What is the difference between the highest and the second highest Value added (in %) of Burundi?
Ensure brevity in your answer.  1.61. What is the difference between the highest and the second highest Value added (in %) of Iceland?
Provide a succinct answer. 0.54. What is the difference between the highest and the second highest Value added (in %) in Senegal?
Provide a short and direct response. 0.43. What is the difference between the highest and the lowest Value added (in %) of Algeria?
Ensure brevity in your answer.  4.87. What is the difference between the highest and the lowest Value added (in %) in Burundi?
Your answer should be compact. 5.17. What is the difference between the highest and the lowest Value added (in %) in Iceland?
Make the answer very short. 3.09. What is the difference between the highest and the lowest Value added (in %) in Senegal?
Ensure brevity in your answer.  16.4. 